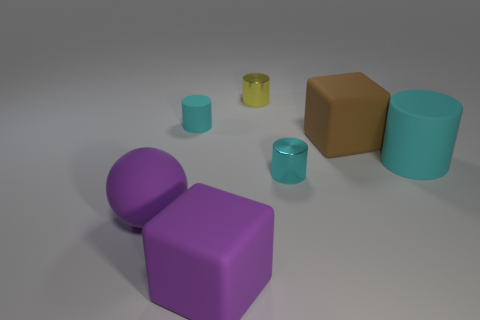Subtract all purple spheres. How many cyan cylinders are left? 3 Add 2 large purple blocks. How many objects exist? 9 Subtract all spheres. How many objects are left? 6 Add 5 large spheres. How many large spheres are left? 6 Add 3 gray objects. How many gray objects exist? 3 Subtract 0 blue cylinders. How many objects are left? 7 Subtract all big purple metallic cubes. Subtract all tiny matte objects. How many objects are left? 6 